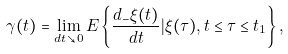Convert formula to latex. <formula><loc_0><loc_0><loc_500><loc_500>\gamma ( t ) = \lim _ { d t \searrow 0 } E \left \{ \frac { d _ { - } \xi ( t ) } { d t } | \xi ( \tau ) , t \leq \tau \leq t _ { 1 } \right \} ,</formula> 